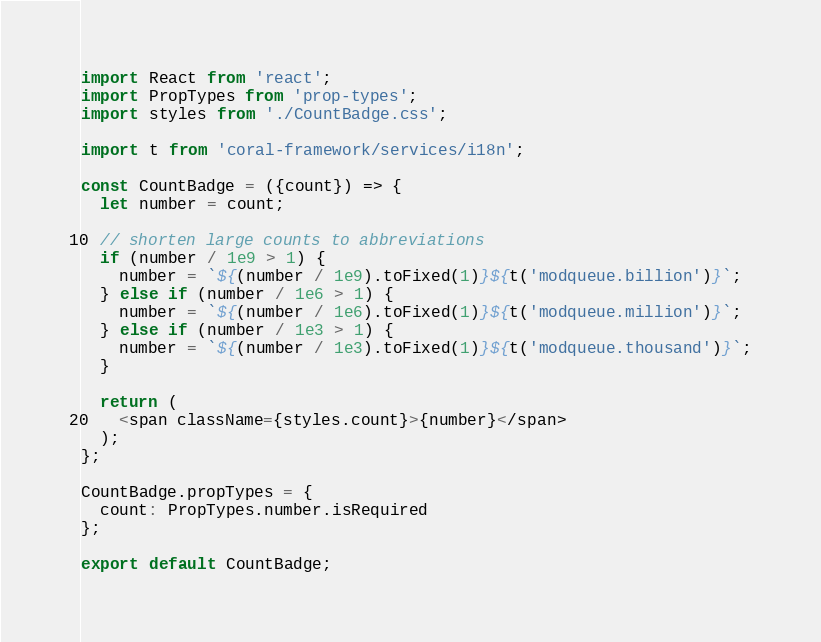<code> <loc_0><loc_0><loc_500><loc_500><_JavaScript_>import React from 'react';
import PropTypes from 'prop-types';
import styles from './CountBadge.css';

import t from 'coral-framework/services/i18n';

const CountBadge = ({count}) => {
  let number = count;

  // shorten large counts to abbreviations
  if (number / 1e9 > 1) {
    number = `${(number / 1e9).toFixed(1)}${t('modqueue.billion')}`;
  } else if (number / 1e6 > 1) {
    number = `${(number / 1e6).toFixed(1)}${t('modqueue.million')}`;
  } else if (number / 1e3 > 1) {
    number = `${(number / 1e3).toFixed(1)}${t('modqueue.thousand')}`;
  }

  return (
    <span className={styles.count}>{number}</span>
  );
};

CountBadge.propTypes = {
  count: PropTypes.number.isRequired
};

export default CountBadge;
</code> 